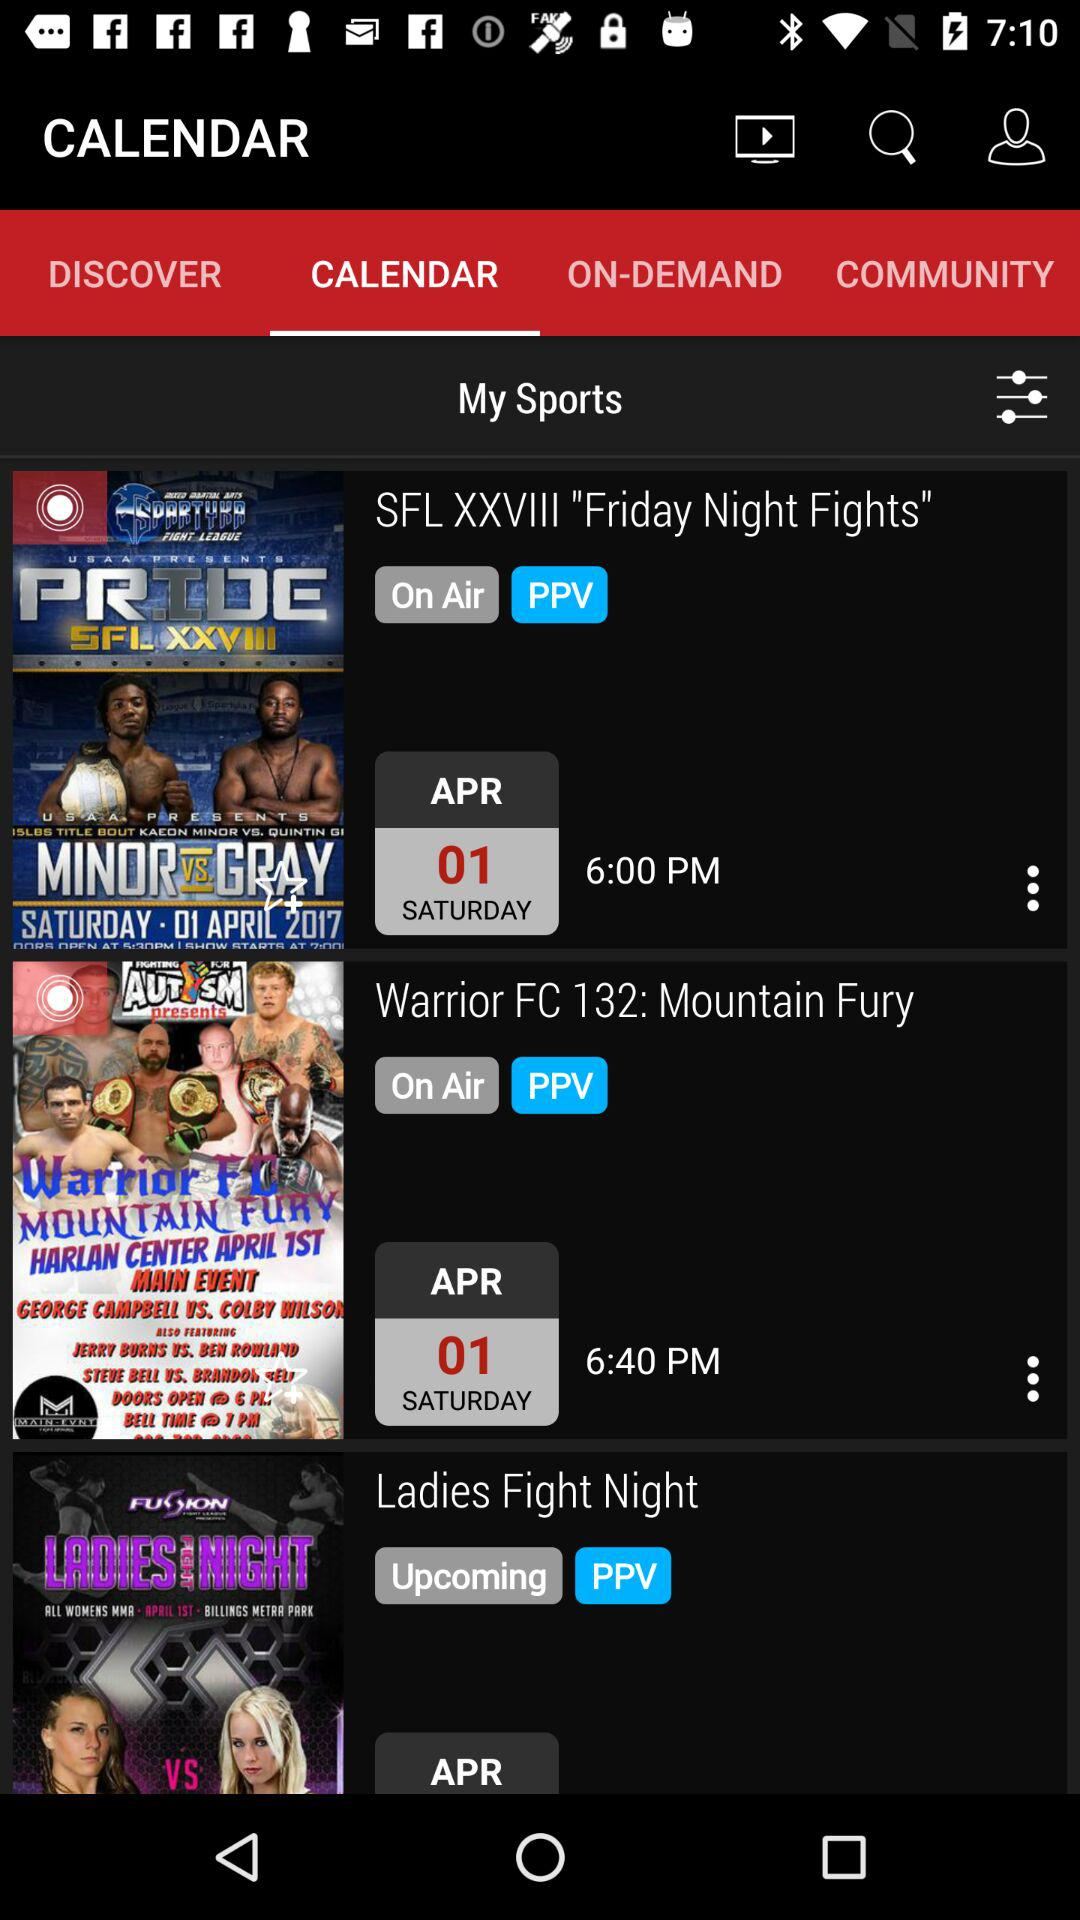What is the given date for "SFL XXVIII "Friday Night Fights""? The given date for "SFL XXVIII "Friday Night Fights"" is Saturday, April 1. 